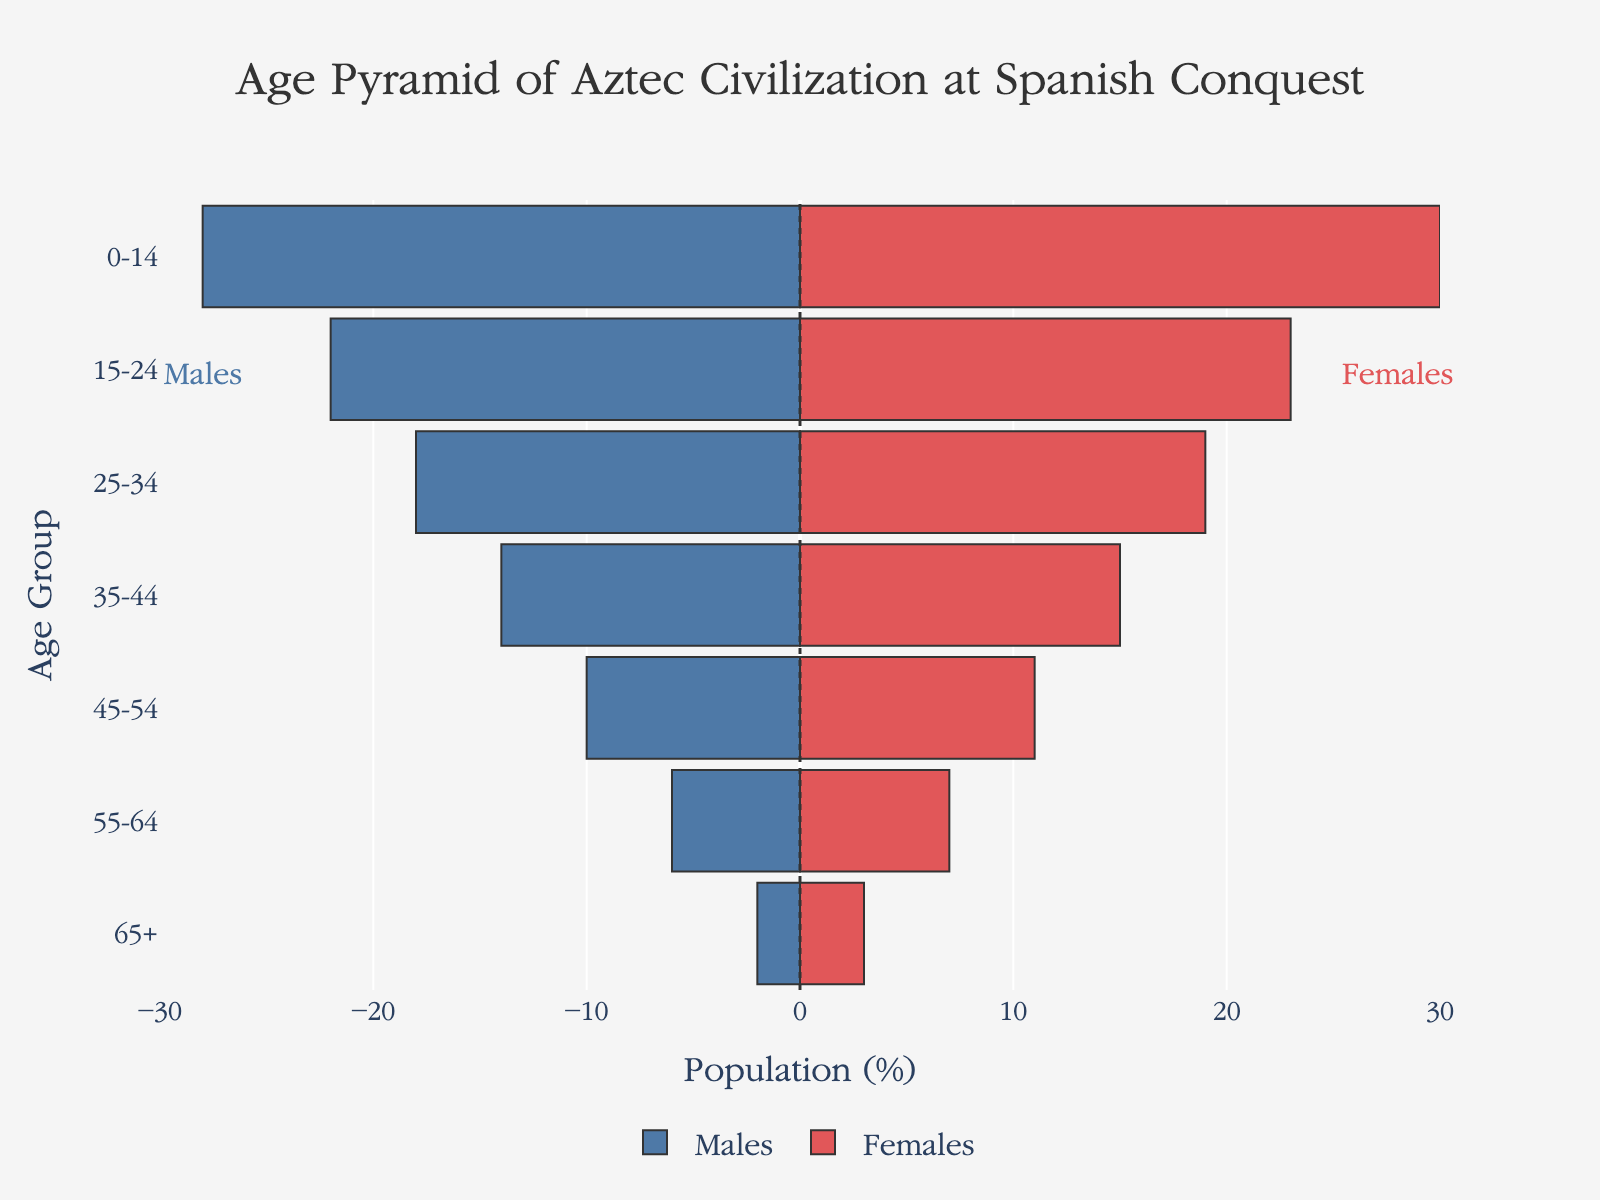What is the population of males in the 25-34 age group? The bar labeled "25-34" in the male section indicates a value of -18, meaning there are 18 males in this age group.
Answer: 18 What is the title of the plot? The title of the plot is displayed at the top and reads "Age Pyramid of Aztec Civilization at Spanish Conquest."
Answer: Age Pyramid of Aztec Civilization at Spanish Conquest Which age group has the smallest population? The bars for both "Males" and "Females" for the "65+" age group are the shortest, indicating the smallest population, with values of 2 and 3 respectively.
Answer: 65+ How many more females are there than males in the 45-54 age group? The female bar for "45-54" has a value of 11, while the male bar has a value of 10. Subtracting 10 from 11 gives the difference of 1.
Answer: 1 What is the total population of people in the 15-24 age group? To find the total, add the male population (22) and the female population (23) for the 15-24 age group, resulting in 45.
Answer: 45 What age group has the largest male population? The longest bar on the male side is for the "0-14" age group, indicating it has the highest population with 28 males.
Answer: 0-14 Is the female population in the 35-44 age group greater or smaller than the male population in the same group? The female population in the 35-44 age group is 15, while the male population is 14. Therefore, the female population is greater.
Answer: Greater What is the total number of females in all age groups combined? Sum the female populations across all age groups (30 + 23 + 19 + 15 + 11 + 7 + 3), which equals 108.
Answer: 108 How does the male population in the 55-64 age group compare to that in the 0-14 age group? The male population in the 55-64 age group is 6, whereas in the 0-14 age group it is 28. The 0-14 age group has a significantly higher population.
Answer: 0-14 age group has a higher population 